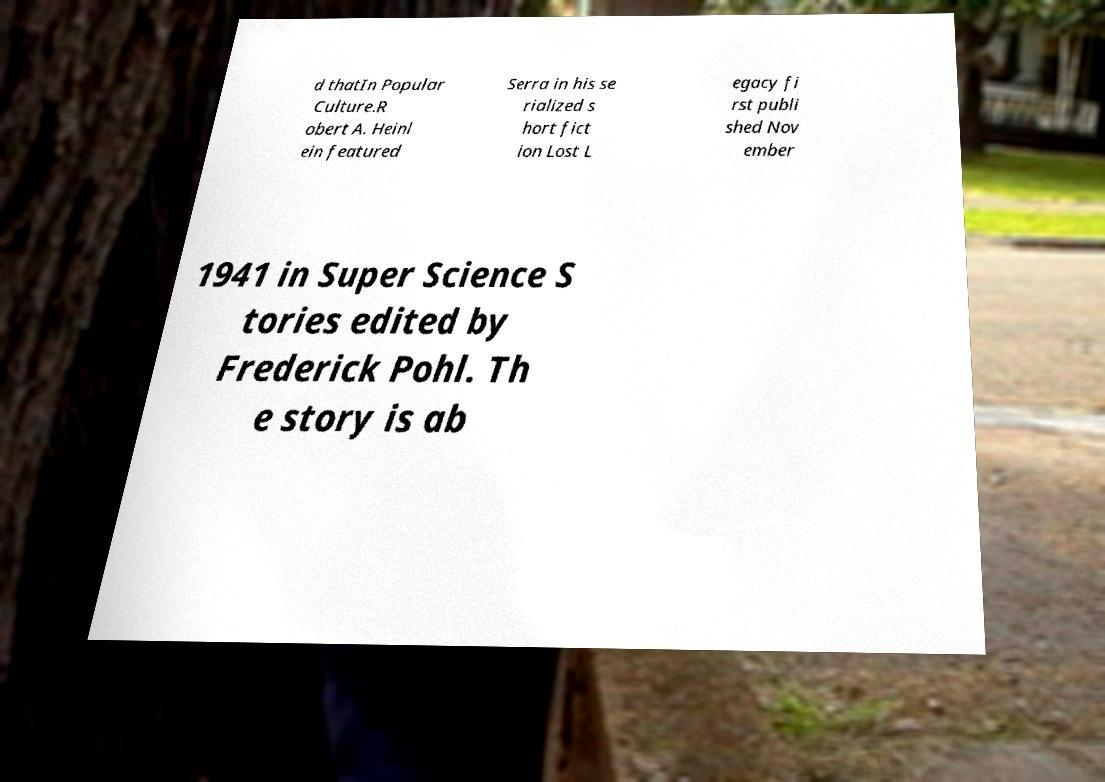I need the written content from this picture converted into text. Can you do that? d thatIn Popular Culture.R obert A. Heinl ein featured Serra in his se rialized s hort fict ion Lost L egacy fi rst publi shed Nov ember 1941 in Super Science S tories edited by Frederick Pohl. Th e story is ab 